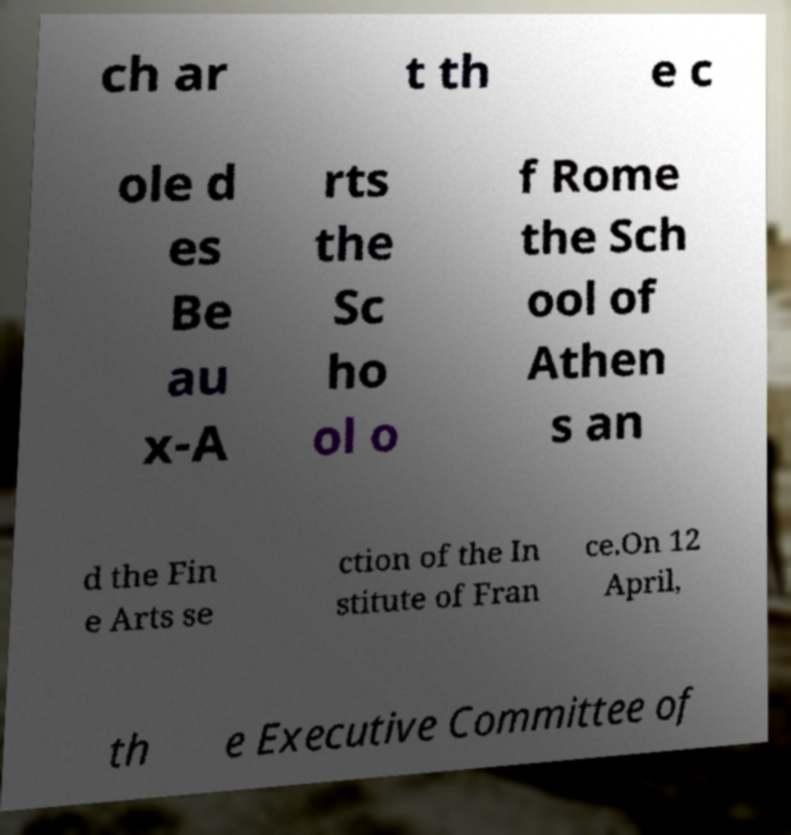There's text embedded in this image that I need extracted. Can you transcribe it verbatim? ch ar t th e c ole d es Be au x-A rts the Sc ho ol o f Rome the Sch ool of Athen s an d the Fin e Arts se ction of the In stitute of Fran ce.On 12 April, th e Executive Committee of 